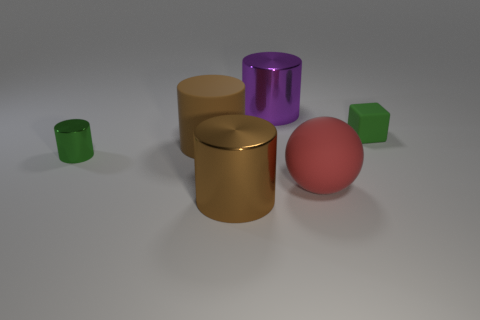There is another brown metal object that is the same shape as the small metallic object; what size is it?
Make the answer very short. Large. There is a big object that is to the left of the brown metallic thing; what is its shape?
Make the answer very short. Cylinder. Does the small object on the left side of the red rubber thing have the same material as the object behind the cube?
Provide a succinct answer. Yes. There is a large brown metallic object; what shape is it?
Provide a short and direct response. Cylinder. Is the number of big brown cylinders that are behind the large brown shiny cylinder the same as the number of red balls?
Provide a short and direct response. Yes. There is a metallic object that is the same color as the matte block; what size is it?
Your answer should be compact. Small. Is there a big purple cylinder made of the same material as the large red ball?
Give a very brief answer. No. There is a rubber thing that is on the left side of the red rubber thing; is it the same shape as the brown object in front of the big red sphere?
Ensure brevity in your answer.  Yes. Is there a yellow cylinder?
Your answer should be very brief. No. There is a matte sphere that is the same size as the brown metallic object; what color is it?
Offer a very short reply. Red. 